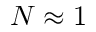<formula> <loc_0><loc_0><loc_500><loc_500>N \approx 1</formula> 